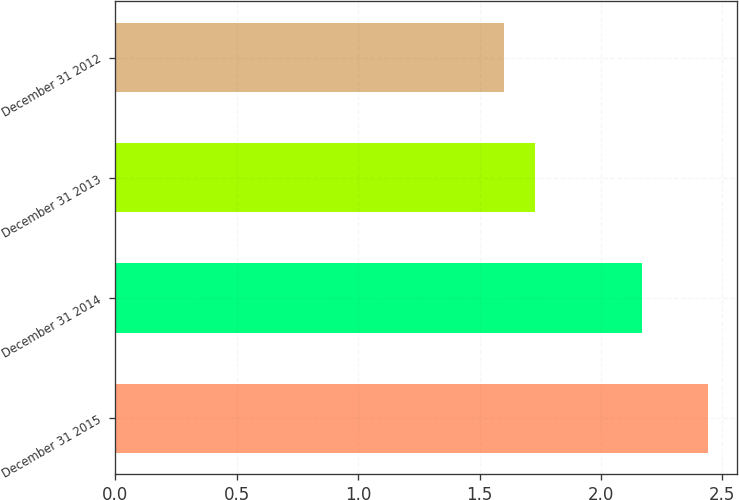Convert chart to OTSL. <chart><loc_0><loc_0><loc_500><loc_500><bar_chart><fcel>December 31 2015<fcel>December 31 2014<fcel>December 31 2013<fcel>December 31 2012<nl><fcel>2.44<fcel>2.17<fcel>1.73<fcel>1.6<nl></chart> 